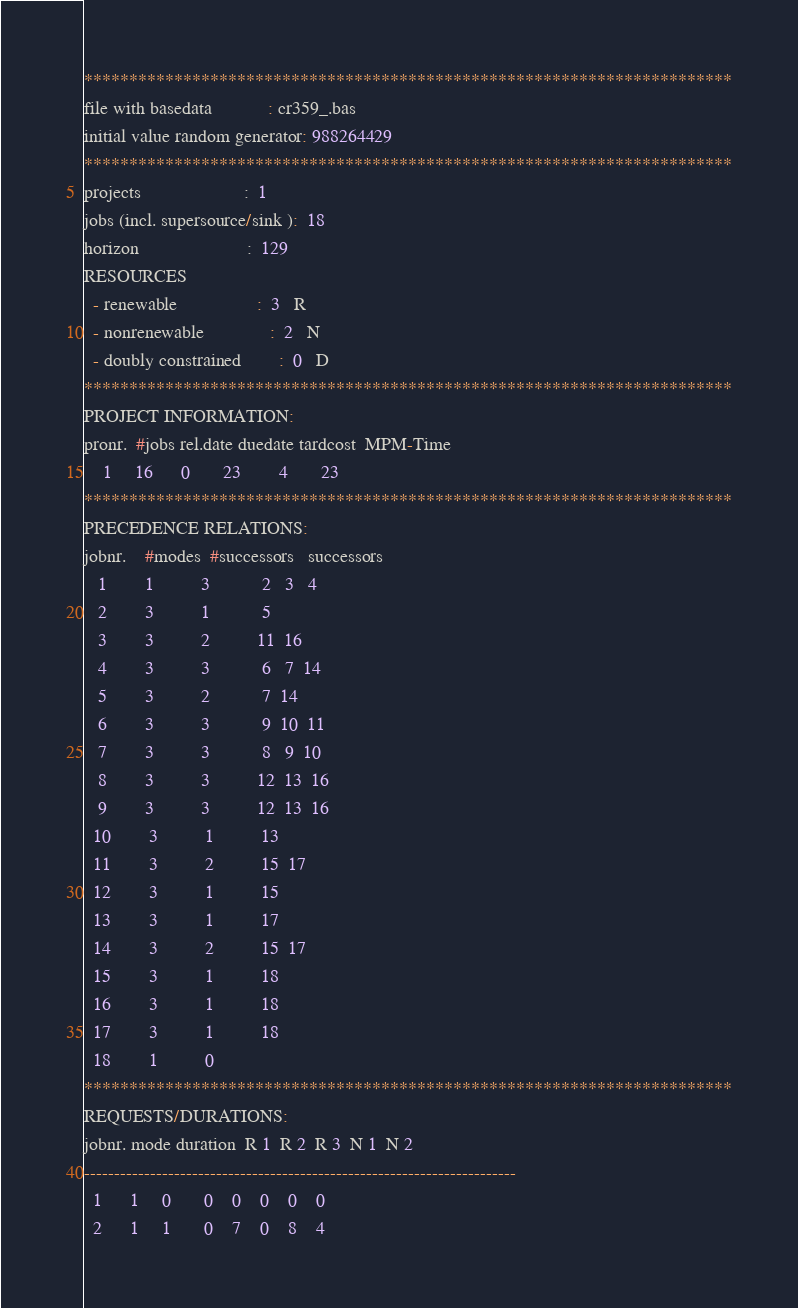<code> <loc_0><loc_0><loc_500><loc_500><_ObjectiveC_>************************************************************************
file with basedata            : cr359_.bas
initial value random generator: 988264429
************************************************************************
projects                      :  1
jobs (incl. supersource/sink ):  18
horizon                       :  129
RESOURCES
  - renewable                 :  3   R
  - nonrenewable              :  2   N
  - doubly constrained        :  0   D
************************************************************************
PROJECT INFORMATION:
pronr.  #jobs rel.date duedate tardcost  MPM-Time
    1     16      0       23        4       23
************************************************************************
PRECEDENCE RELATIONS:
jobnr.    #modes  #successors   successors
   1        1          3           2   3   4
   2        3          1           5
   3        3          2          11  16
   4        3          3           6   7  14
   5        3          2           7  14
   6        3          3           9  10  11
   7        3          3           8   9  10
   8        3          3          12  13  16
   9        3          3          12  13  16
  10        3          1          13
  11        3          2          15  17
  12        3          1          15
  13        3          1          17
  14        3          2          15  17
  15        3          1          18
  16        3          1          18
  17        3          1          18
  18        1          0        
************************************************************************
REQUESTS/DURATIONS:
jobnr. mode duration  R 1  R 2  R 3  N 1  N 2
------------------------------------------------------------------------
  1      1     0       0    0    0    0    0
  2      1     1       0    7    0    8    4</code> 